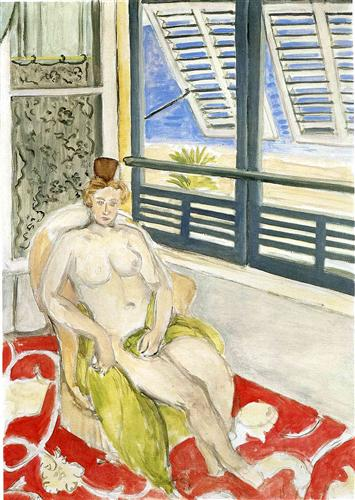What do you see happening in this image? This image is an evocative piece of art that depicts a nude woman with blonde hair seated on a vibrant, red and white rug. She appears contemplative, her gaze slightly averted, suggesting introspection. The interior setting is composed of blue and white tiles, which furnish the space with a cool, meditative palette, contrasting with the warmth of the woman's skin and the rug. The partially opened blue shutters reveal a serene outdoor landscape, inviting the viewer to ponder the connection between the woman and the world beyond. The painting employs a post-impressionist style, with brush strokes that add lively texture and a sense of movement. This style emphasizes the emotional and symbolic content of the scene over strict realism, leaving the viewer with a strong impression of solitude and tranquility. 